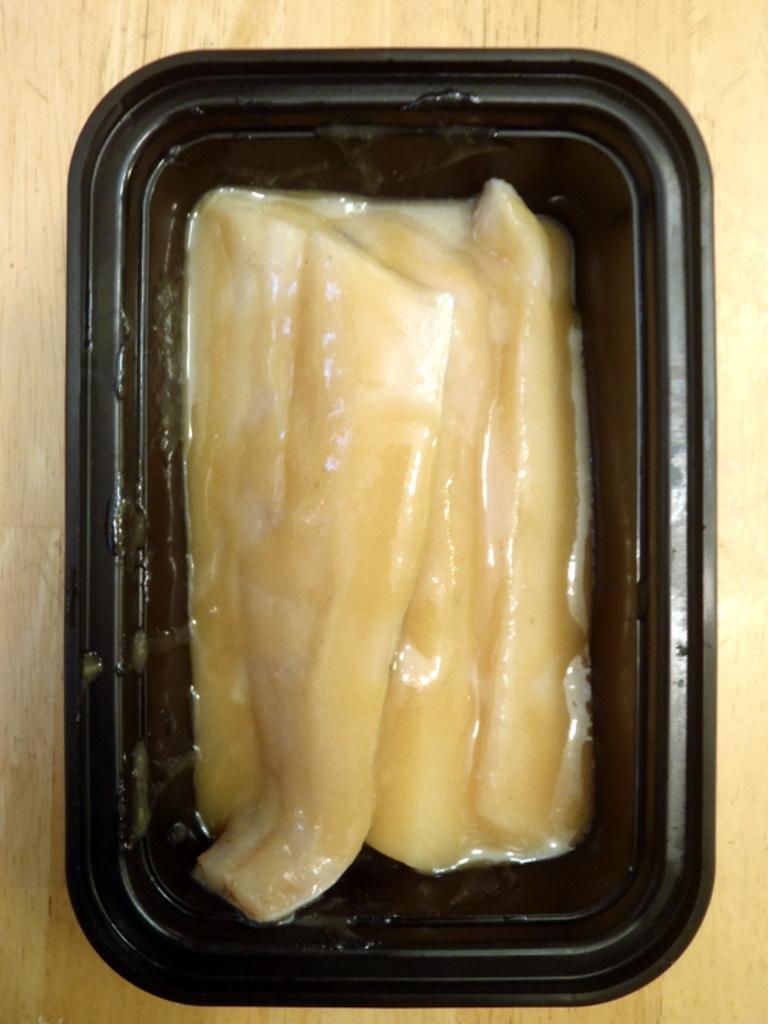Can you describe this image briefly? We can see food in a black color box on wooden surface. 